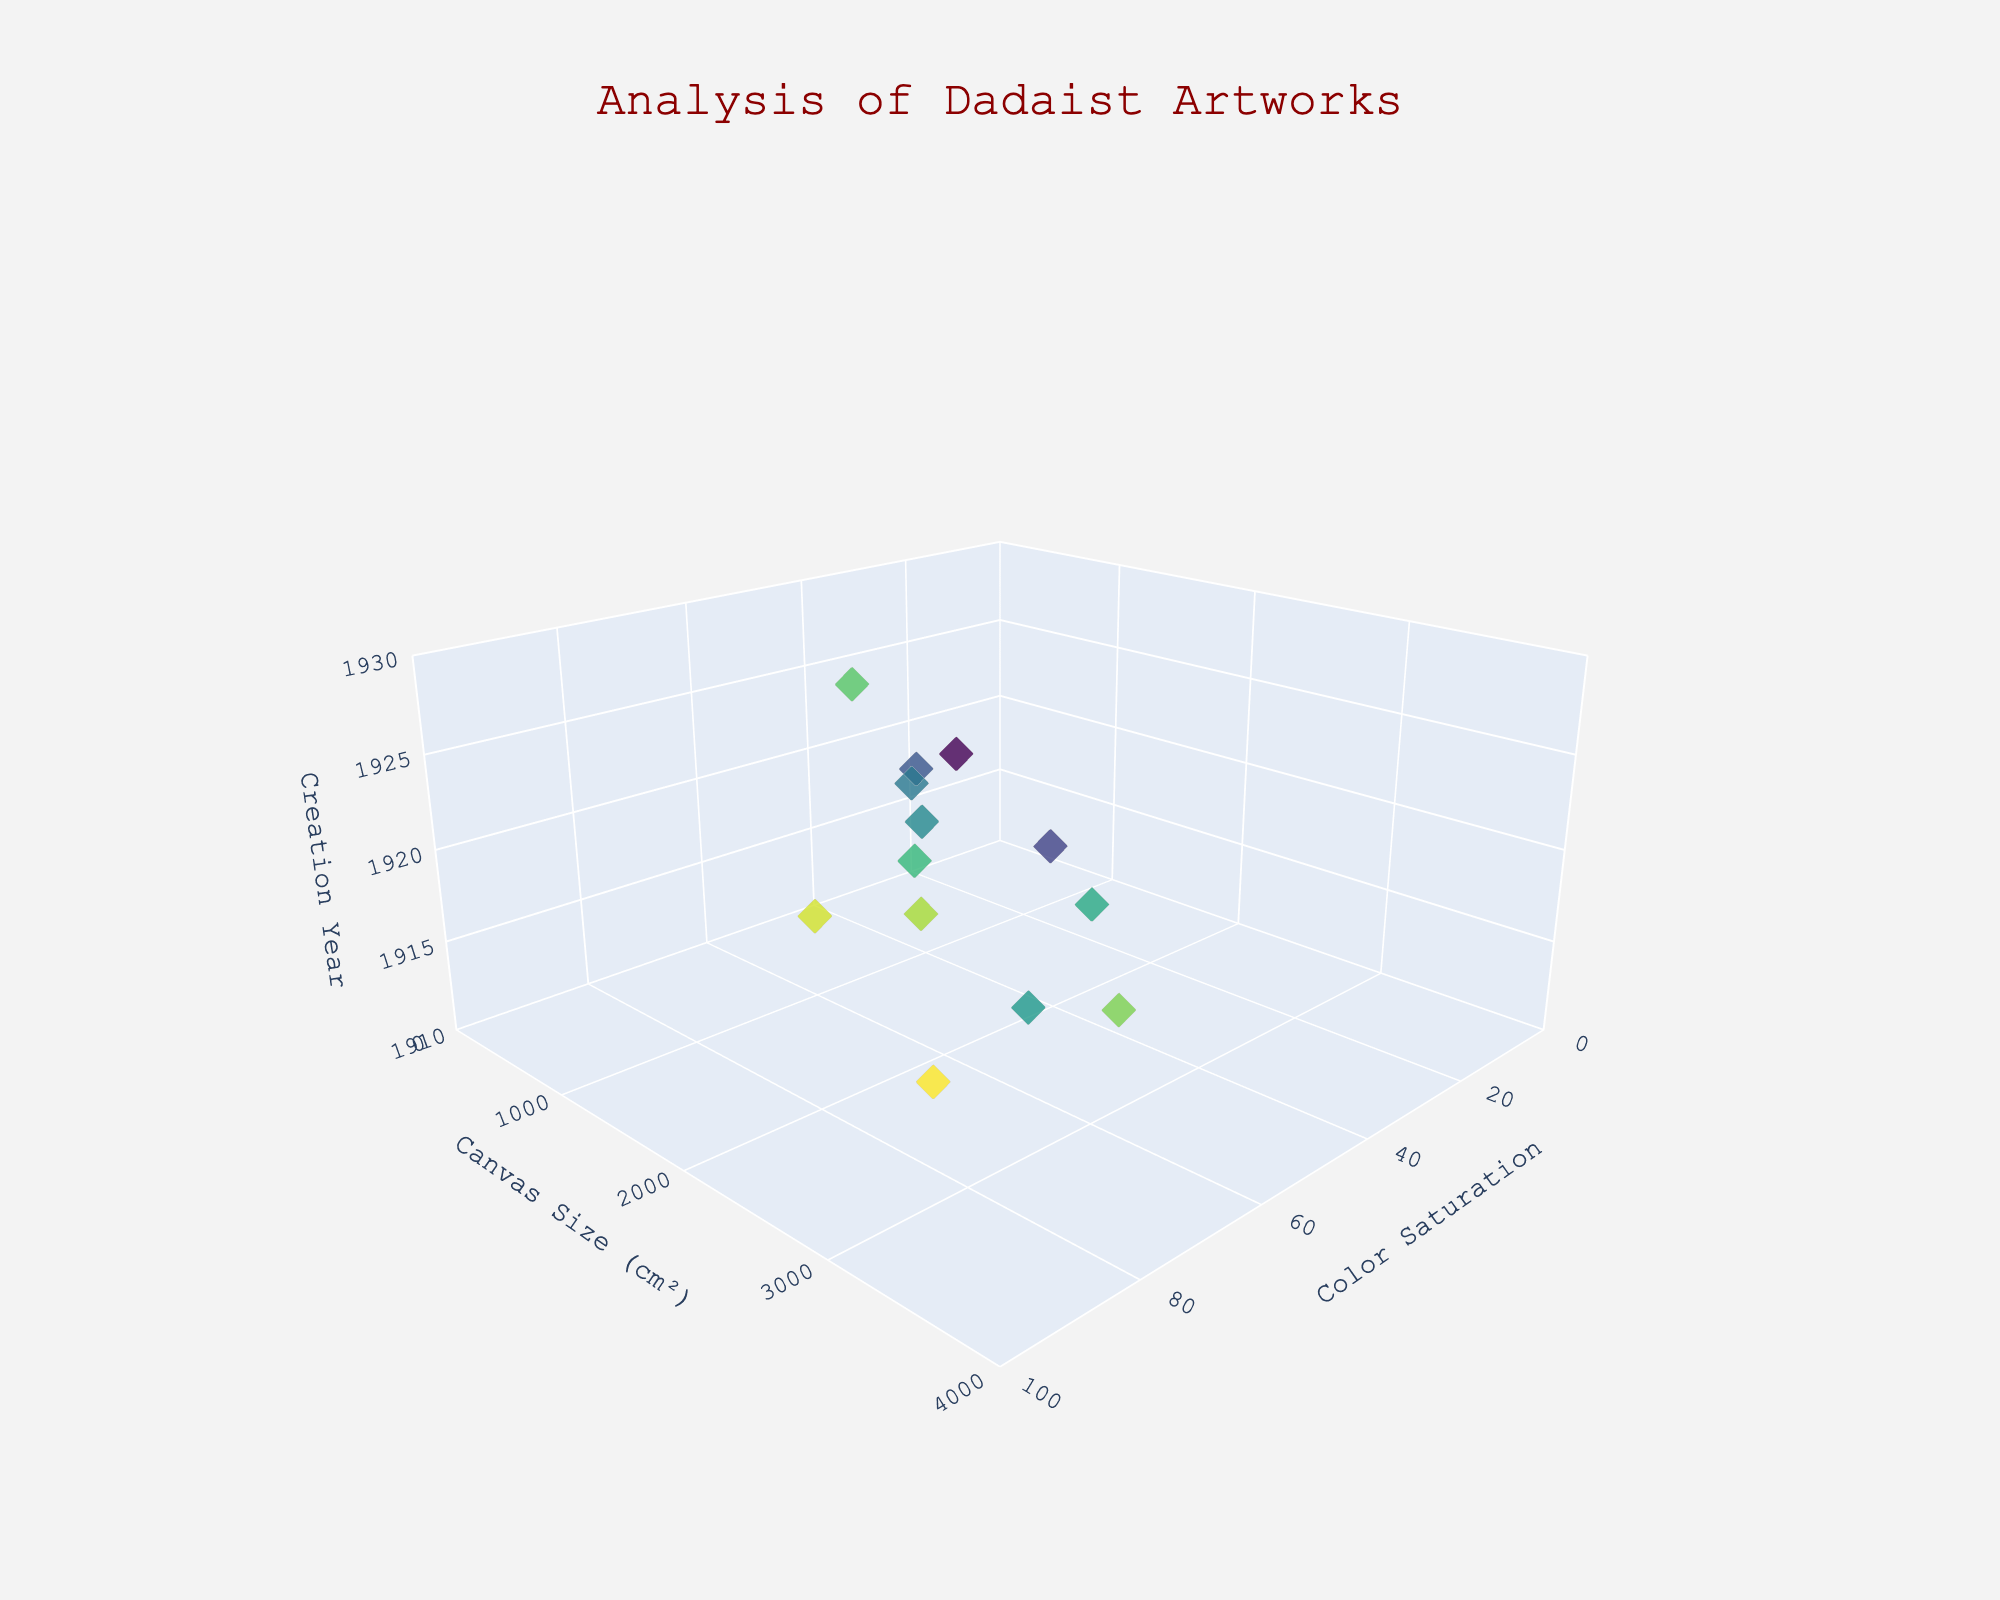What is the title of the 3D scatter plot? The title of the 3D scatter plot is prominently displayed at the top of the figure.
Answer: Analysis of Dadaist Artworks What does the x-axis represent? The x-axis represents color saturation, which can be gleaned by looking at the axis title near the bottom of the plot.
Answer: Color Saturation What artwork was created in 1917 and where is it located on the plot? The artwork created in 1917 is 'Fountain (Marcel Duchamp). By looking at the z-axis (creation year) at 1917, we can find the data point at color saturation of 10 and canvas size of 0.
Answer: 'Fountain (Marcel Duchamp)' How many artworks were created in the year 1919? All the points corresponding to the year 1919 on the z-axis should be counted. There are four such points.
Answer: 4 Which artwork has the highest canvas size? Identify the point on the plot with the highest value on the y-axis (canvas size) and locate the associated artwork name in the hover information.
Answer: 'Cut with the Dada Kitchen Knife (Hannah Höch)' What is the average color saturation of artworks created before 1920? Sum the color saturation values for artworks created before 1920 (1912, 1916, 1917, 1919) and divide by the number of such artworks.
Answer: (50+25+85+10+30+70+45)/7 = 315/7 = 45 Which artwork has the lowest color saturation and what is its creation year? Locate the point with the lowest color saturation on the x-axis and identify its creation year by following the z-axis.
Answer: 'Fountain (Marcel Duchamp)', 1917 Compare the canvas size of 'The Bride Stripped Bare' and 'Cabaret Voltaire'. Which one is larger? Locate the points for 'The Bride Stripped Bare (Francis Picabia)' and 'Cabaret Voltaire (Marcel Janco)' on the plot and compare their canvas size values on the y-axis.
Answer: 'Cabaret Voltaire (Marcel Janco)' How does 'L.H.O.O.Q.' compare in color saturation and canvas size to 'Dada Siegt'? Identify the two artworks on the plot and compare their respective x (color saturation) and y (canvas size) values.
Answer: 'Dada Siegt' has higher color saturation and larger canvas size than 'L.H.O.O.Q.' Identify the range of creation years covered in the plot. Examine the z-axis and identify the minimum and maximum creation years represented by the data points on the plot.
Answer: 1912 to 1929 